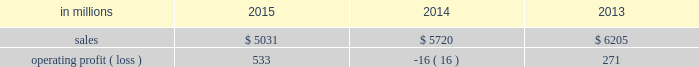Compared with $ 6.2 billion in 2013 .
Operating profits in 2015 were significantly higher than in both 2014 and 2013 .
Excluding facility closure costs , impairment costs and other special items , operating profits in 2015 were 3% ( 3 % ) lower than in 2014 and 4% ( 4 % ) higher than in 2013 .
Benefits from lower input costs ( $ 18 million ) , lower costs associated with the closure of our courtland , alabama mill ( $ 44 million ) and favorable foreign exchange ( $ 33 million ) were offset by lower average sales price realizations and mix ( $ 52 million ) , lower sales volumes ( $ 16 million ) , higher operating costs ( $ 18 million ) and higher planned maintenance downtime costs ( $ 26 million ) .
In addition , operating profits in 2014 include special items costs of $ 554 million associated with the closure of our courtland , alabama mill .
During 2013 , the company accelerated depreciation for certain courtland assets , and evaluated certain other assets for possible alternative uses by one of our other businesses .
The net book value of these assets at december 31 , 2013 was approximately $ 470 million .
In the first quarter of 2014 , we completed our evaluation and concluded that there were no alternative uses for these assets .
We recognized approximately $ 464 million of accelerated depreciation related to these assets in 2014 .
Operating profits in 2014 also include a charge of $ 32 million associated with a foreign tax amnesty program , and a gain of $ 20 million for the resolution of a legal contingency in india , while operating profits in 2013 included costs of $ 118 million associated with the announced closure of our courtland , alabama mill and a $ 123 million impairment charge associated with goodwill and a trade name intangible asset in our india papers business .
Printing papers .
North american printing papers net sales were $ 1.9 billion in 2015 , $ 2.1 billion in 2014 and $ 2.6 billion in 2013 .
Operating profits in 2015 were $ 179 million compared with a loss of $ 398 million ( a gain of $ 156 million excluding costs associated with the shutdown of our courtland , alabama mill ) in 2014 and a gain of $ 36 million ( $ 154 million excluding costs associated with the courtland mill shutdown ) in 2013 .
Sales volumes in 2015 decreased compared with 2014 primarily due to the closure of our courtland mill in 2014 .
Shipments to the domestic market increased , but export shipments declined .
Average sales price realizations decreased , primarily in the domestic market .
Input costs were lower , mainly for energy .
Planned maintenance downtime costs were $ 12 million higher in 2015 .
Operating profits in 2014 were negatively impacted by costs associated with the shutdown of our courtland , alabama mill .
Entering the first quarter of 2016 , sales volumes are expected to be up slightly compared with the fourth quarter of 2015 .
Average sales margins should be about flat reflecting lower average sales price realizations offset by a more favorable product mix .
Input costs are expected to be stable .
Planned maintenance downtime costs are expected to be about $ 14 million lower with an outage scheduled in the 2016 first quarter at our georgetown mill compared with outages at our eastover and riverdale mills in the 2015 fourth quarter .
In january 2015 , the united steelworkers , domtar corporation , packaging corporation of america , finch paper llc and p .
Glatfelter company ( the petitioners ) filed an anti-dumping petition before the united states international trade commission ( itc ) and the united states department of commerce ( doc ) alleging that paper producers in china , indonesia , australia , brazil , and portugal are selling uncoated free sheet paper in sheet form ( the products ) in violation of international trade rules .
The petitioners also filed a countervailing-duties petition with these agencies regarding imports of the products from china and indonesia .
In january 2016 , the doc announced its final countervailing duty rates on imports of the products to the united states from certain producers from china and indonesia .
Also , in january 2016 , the doc announced its final anti-dumping duty rates on imports of the products to the united states from certain producers from australia , brazil , china , indonesia and portugal .
In february 2016 , the itc concluded its anti- dumping and countervailing duties investigations and made a final determination that the u.s .
Market had been injured by imports of the products .
Accordingly , the doc 2019s previously announced countervailing duty rates and anti-dumping duty rates will be in effect for a minimum of five years .
We do not believe the impact of these rates will have a material , adverse effect on our consolidated financial statements .
Brazilian papers net sales for 2015 were $ 878 million compared with $ 1.1 billion in 2014 and $ 1.1 billion in 2013 .
Operating profits for 2015 were $ 186 million compared with $ 177 million ( $ 209 million excluding costs associated with a tax amnesty program ) in 2014 and $ 210 million in 2013 .
Sales volumes in 2015 were lower compared with 2014 reflecting weak economic conditions and the absence of 2014 one-time events .
Average sales price realizations improved for domestic uncoated freesheet paper due to the realization of price increases implemented in the second half of 2015 .
Margins were unfavorably affected by an increased proportion of sales to the lower-margin export markets .
Raw material costs increased for energy and wood .
Operating costs were higher than in 2014 , while planned maintenance downtime costs were $ 4 million lower. .
What was the percentage change in operating profits in 2015? 
Computations: ((186 - 177) / 177)
Answer: 0.05085. 